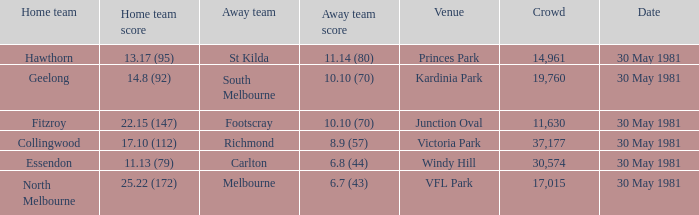What is the home venue of essendon with a crowd larger than 19,760? Windy Hill. 